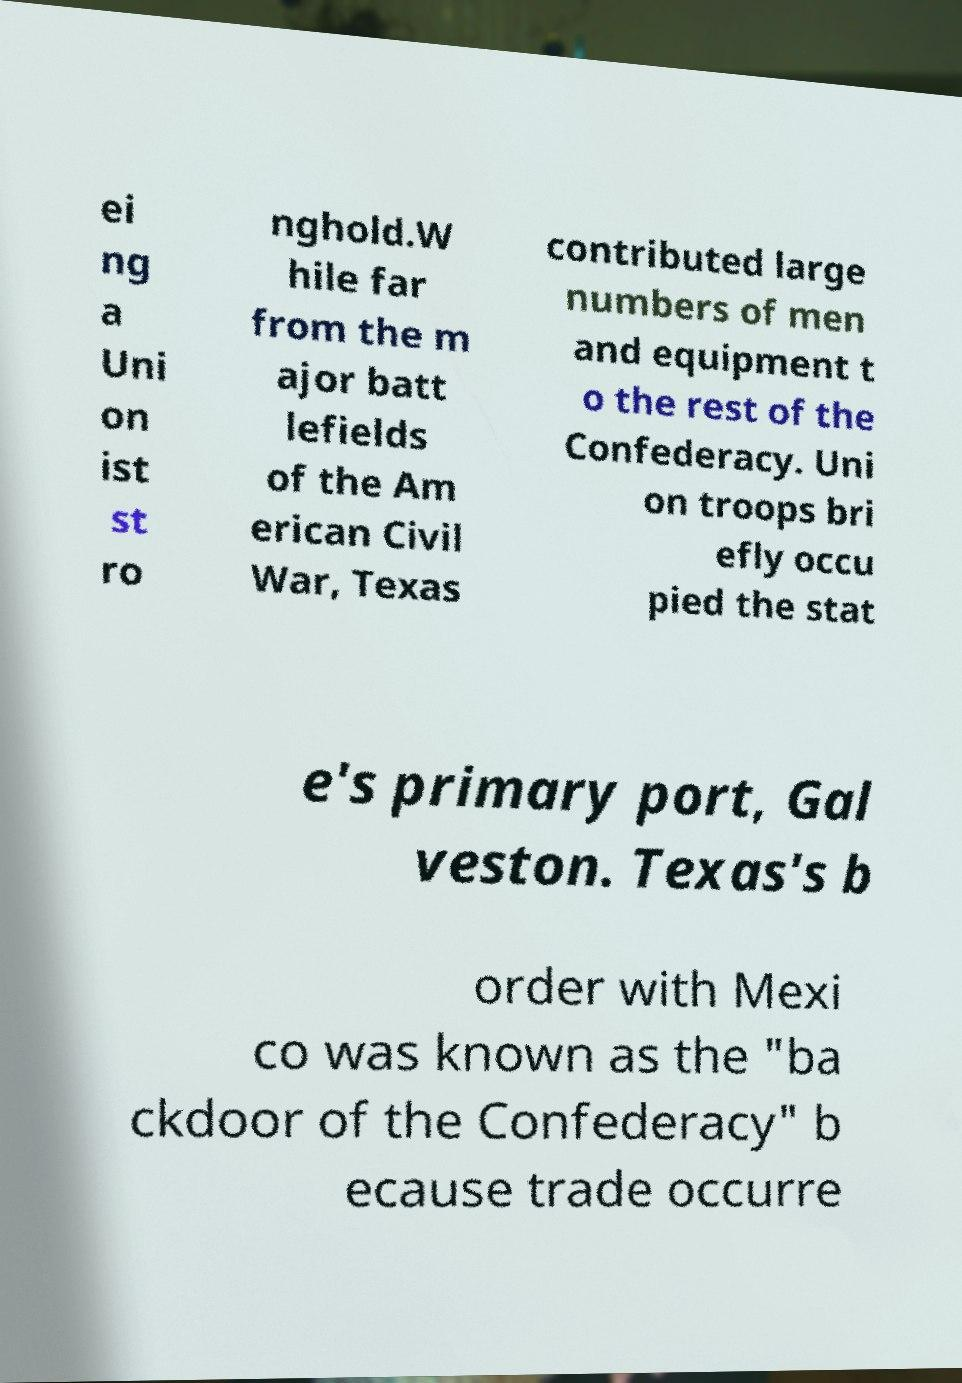Can you accurately transcribe the text from the provided image for me? ei ng a Uni on ist st ro nghold.W hile far from the m ajor batt lefields of the Am erican Civil War, Texas contributed large numbers of men and equipment t o the rest of the Confederacy. Uni on troops bri efly occu pied the stat e's primary port, Gal veston. Texas's b order with Mexi co was known as the "ba ckdoor of the Confederacy" b ecause trade occurre 